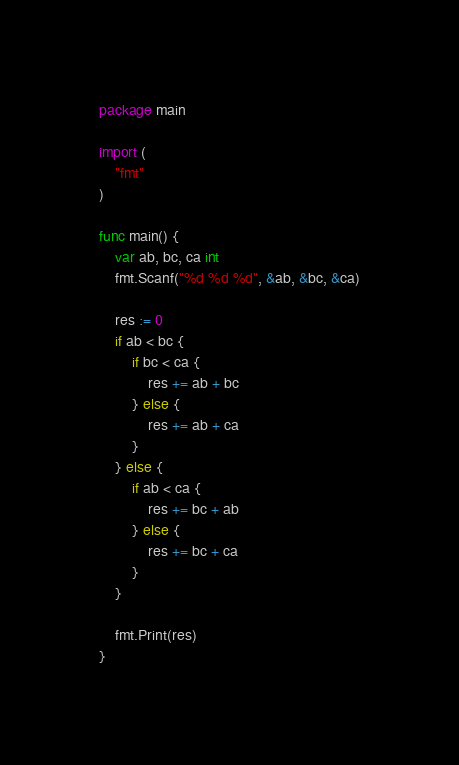<code> <loc_0><loc_0><loc_500><loc_500><_Go_>package main

import (
	"fmt"
)

func main() {
	var ab, bc, ca int
	fmt.Scanf("%d %d %d", &ab, &bc, &ca)

	res := 0
	if ab < bc {
		if bc < ca {
			res += ab + bc
		} else {
			res += ab + ca
		}
	} else {
		if ab < ca {
			res += bc + ab
		} else {
			res += bc + ca
		}
	}

	fmt.Print(res)
}
</code> 